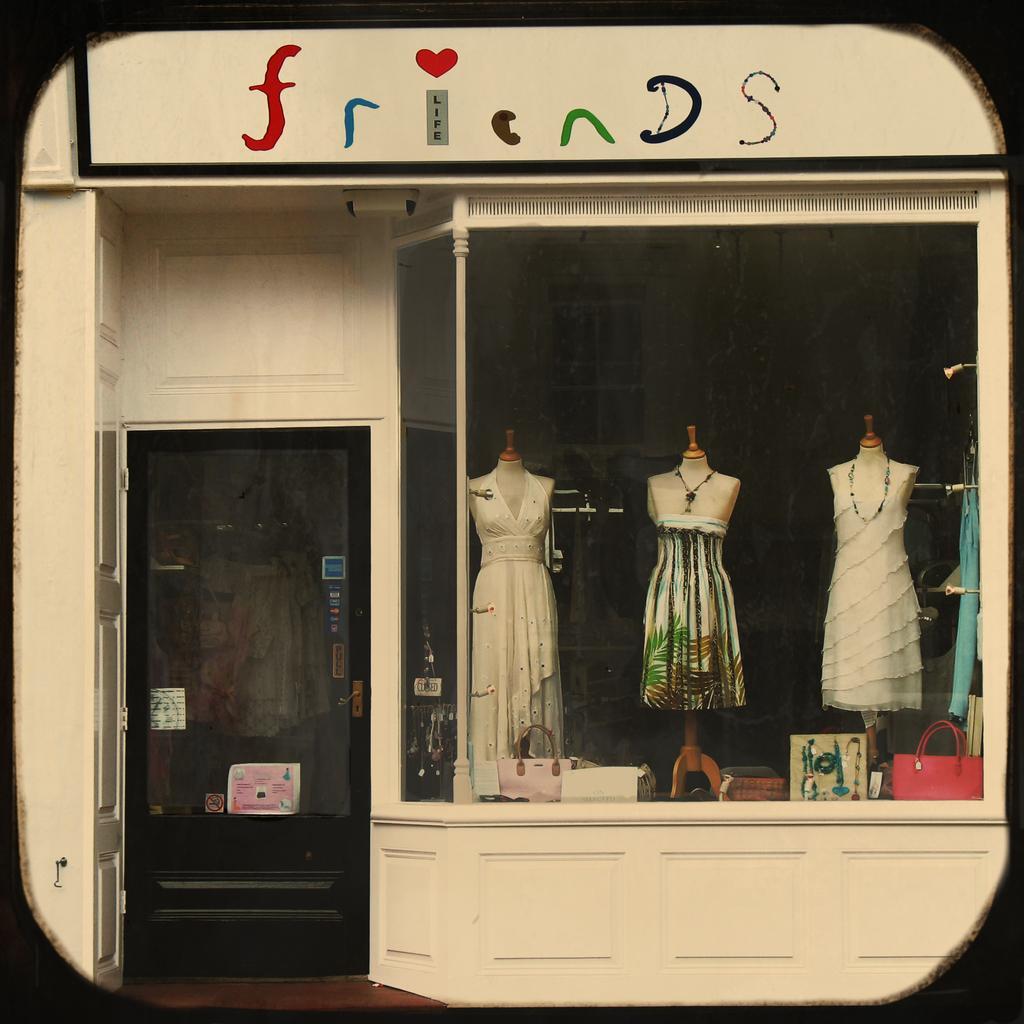In one or two sentences, can you explain what this image depicts? In this image I can see the store. To the right there are two mannequins with white color dresses and one mannequin with colorful dress. There are many bags in-front of these mannequins. To the left I can see the glass door. 